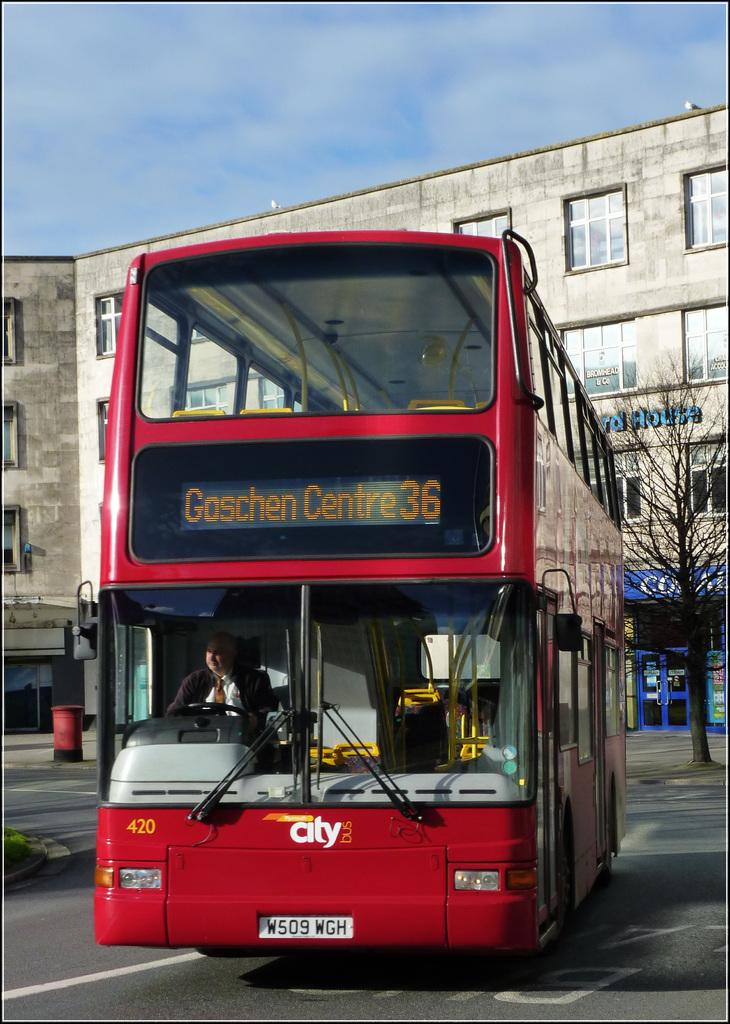<image>
Share a concise interpretation of the image provided. A double decker bus that says Goschen Centre 36 on the front of the bus also showing the driver inside of the bus. 